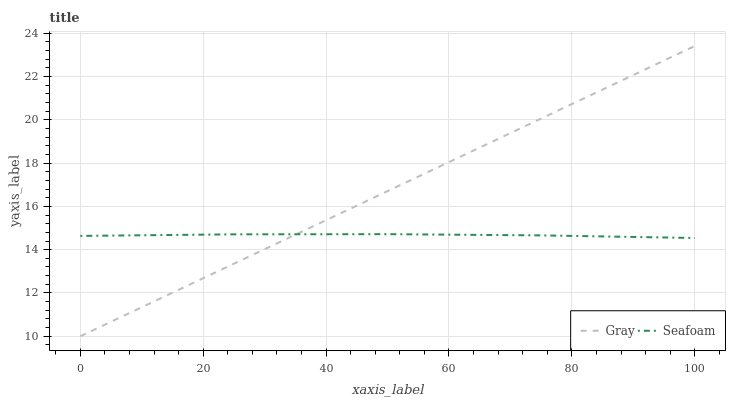Does Seafoam have the minimum area under the curve?
Answer yes or no. Yes. Does Gray have the maximum area under the curve?
Answer yes or no. Yes. Does Seafoam have the maximum area under the curve?
Answer yes or no. No. Is Gray the smoothest?
Answer yes or no. Yes. Is Seafoam the roughest?
Answer yes or no. Yes. Is Seafoam the smoothest?
Answer yes or no. No. Does Seafoam have the lowest value?
Answer yes or no. No. Does Gray have the highest value?
Answer yes or no. Yes. Does Seafoam have the highest value?
Answer yes or no. No. Does Gray intersect Seafoam?
Answer yes or no. Yes. Is Gray less than Seafoam?
Answer yes or no. No. Is Gray greater than Seafoam?
Answer yes or no. No. 